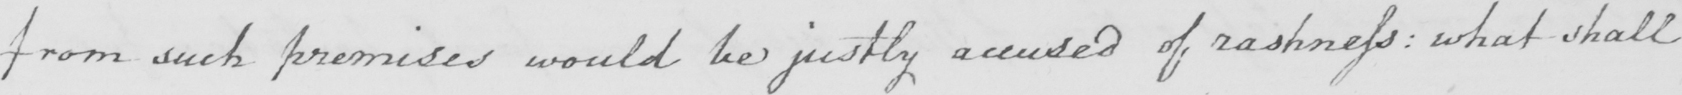Can you tell me what this handwritten text says? from such premises would be justly accused of rashness :  what shall 